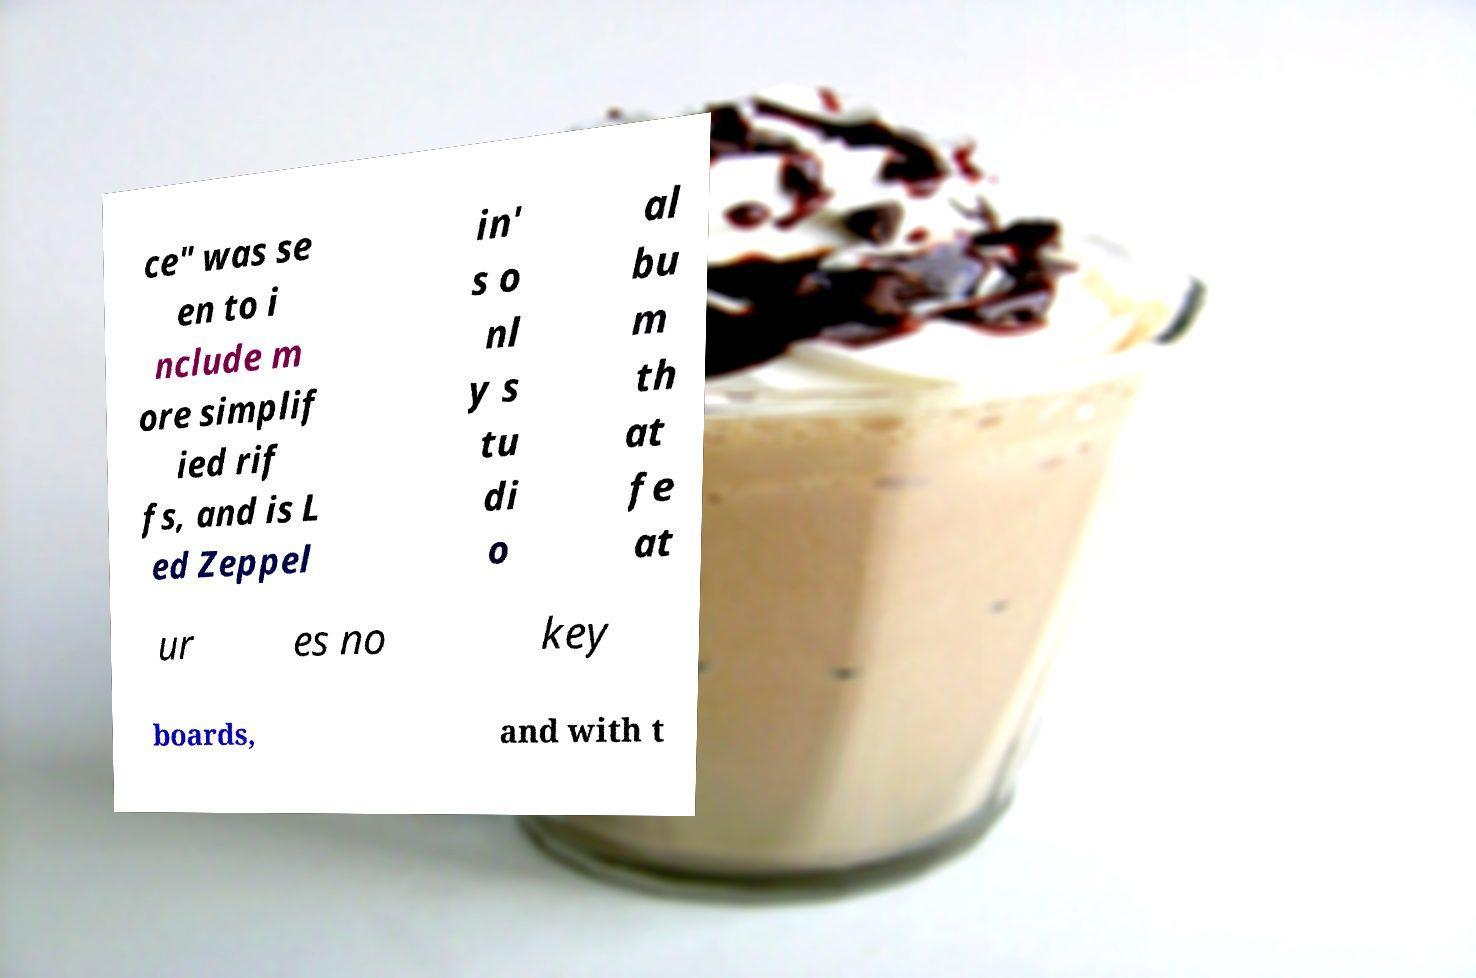Could you assist in decoding the text presented in this image and type it out clearly? ce" was se en to i nclude m ore simplif ied rif fs, and is L ed Zeppel in' s o nl y s tu di o al bu m th at fe at ur es no key boards, and with t 